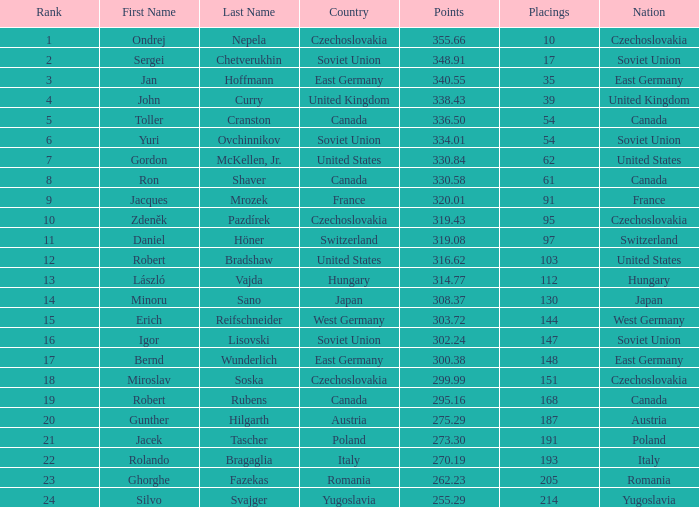Which standings belong to a country of west germany, and points surpassing 30 None. 